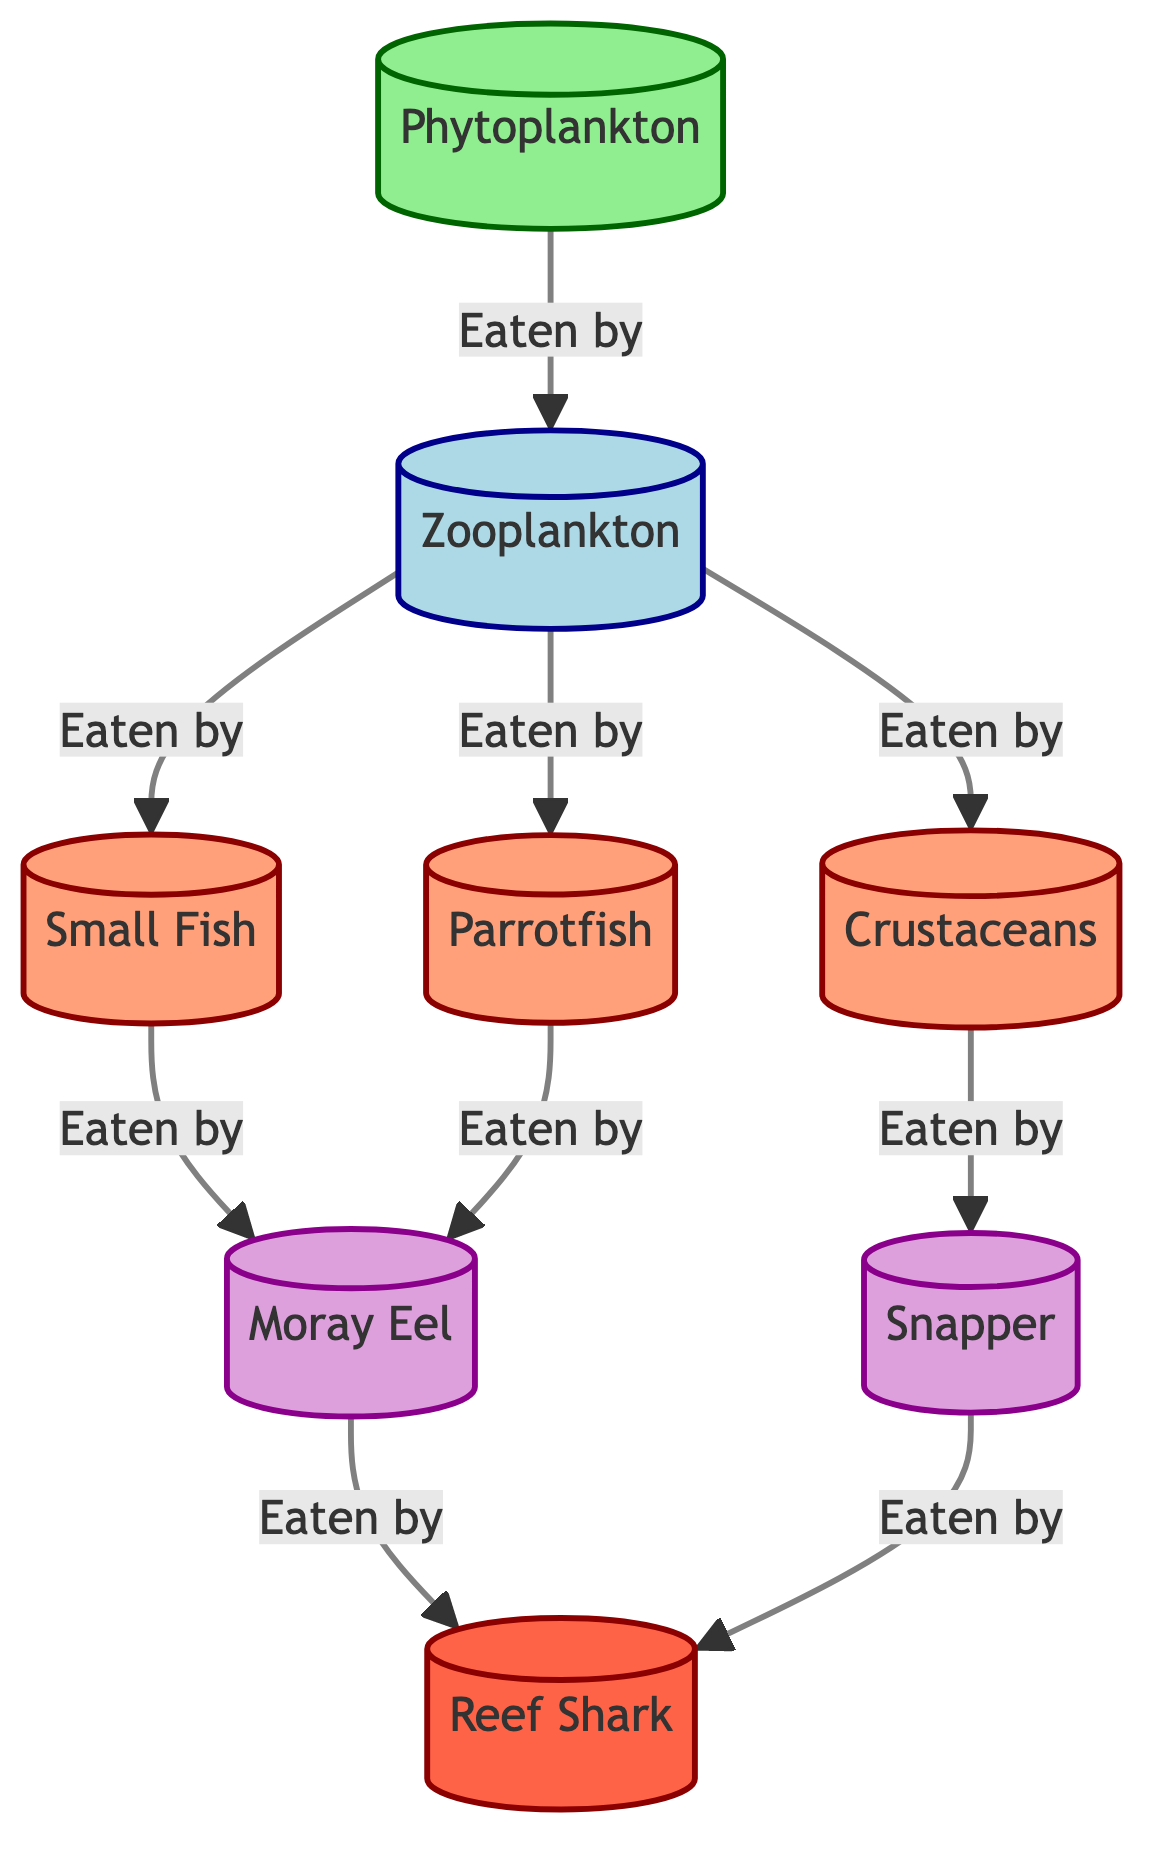What are the primary producers in the coral reef ecosystem? The diagram identifies phytoplankton as the primary producers, represented at the beginning of the food chain.
Answer: Phytoplankton How many apex predators are shown in the diagram? The diagram includes one apex predator, which is the reef shark, located at the end of the food chain.
Answer: 1 Who eats crustaceans? According to the diagram, crustaceans are consumed by the snapper, represented as a tertiary consumer.
Answer: Snapper Which consumer is eaten by both moray eels and parrotfish? The diagram shows that zooplankton is eaten by both the moray eel and the parrotfish, linking them through the food chain.
Answer: Zooplankton What is the relationship between small fish and reef sharks? The relationship indicated in the diagram shows that small fish are eaten by moray eels, which in turn are eaten by reef sharks, highlighting a multi-step predatory relationship.
Answer: Small fish are eaten by moray eels, which are eaten by reef sharks How many secondary consumers are there? The diagram illustrates three secondary consumers: small fish, parrotfish, and crustaceans, which can be counted directly from the connections in the food chain.
Answer: 3 Which primary consumer is related to both parrotfish and small fish? The primary consumer zooplankton is linked to both parrotfish and small fish, as they are all connected to zooplankton through the food chain.
Answer: Zooplankton What color represents tertiary consumers in the diagram? The diagram uses a light purple color for tertiary consumers, distinguishing them from other levels in the food chain.
Answer: Light purple What is the immediate food source for reef sharks? The diagram shows that the immediate food source for reef sharks is the moray eel and snapper, which are both represented as tertiary consumers above them in the food chain.
Answer: Moray eel and Snapper 